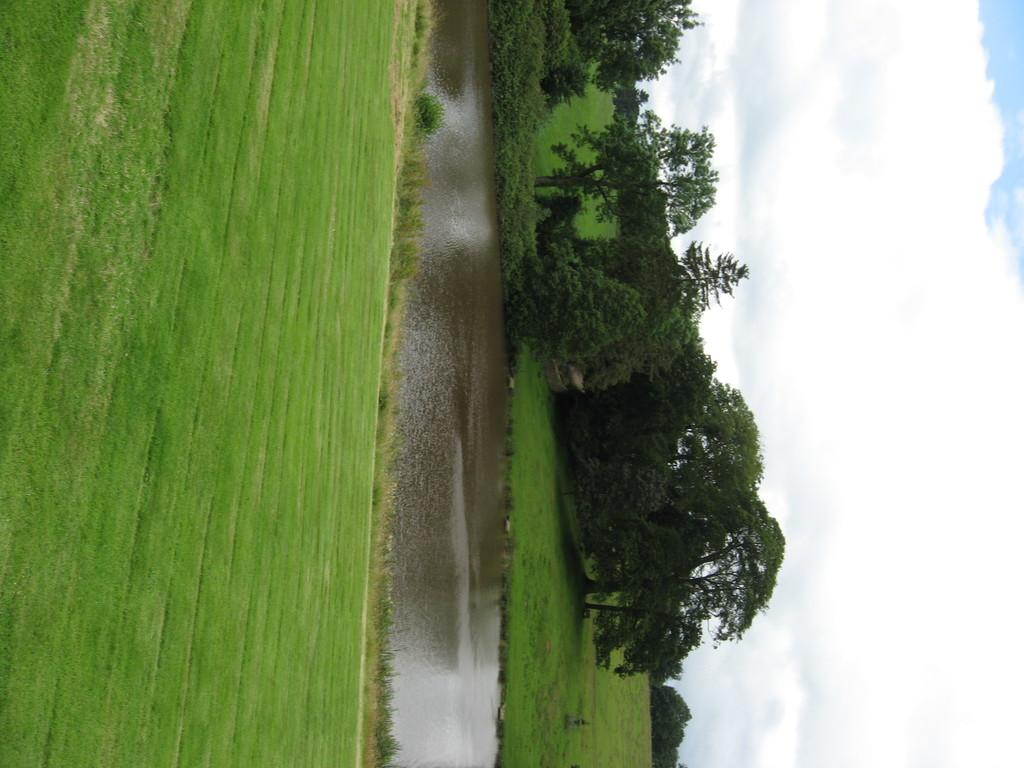What is the main element in the center of the image? There is water in the center of the image. What type of vegetation is present at the bottom of the image? There is grass on the surface at the bottom of the image. What can be seen in the background of the image? There are trees and the sky visible in the background of the image. What type of anger can be seen on the trees in the image? There is no anger present in the image; the trees are simply trees in the background. 